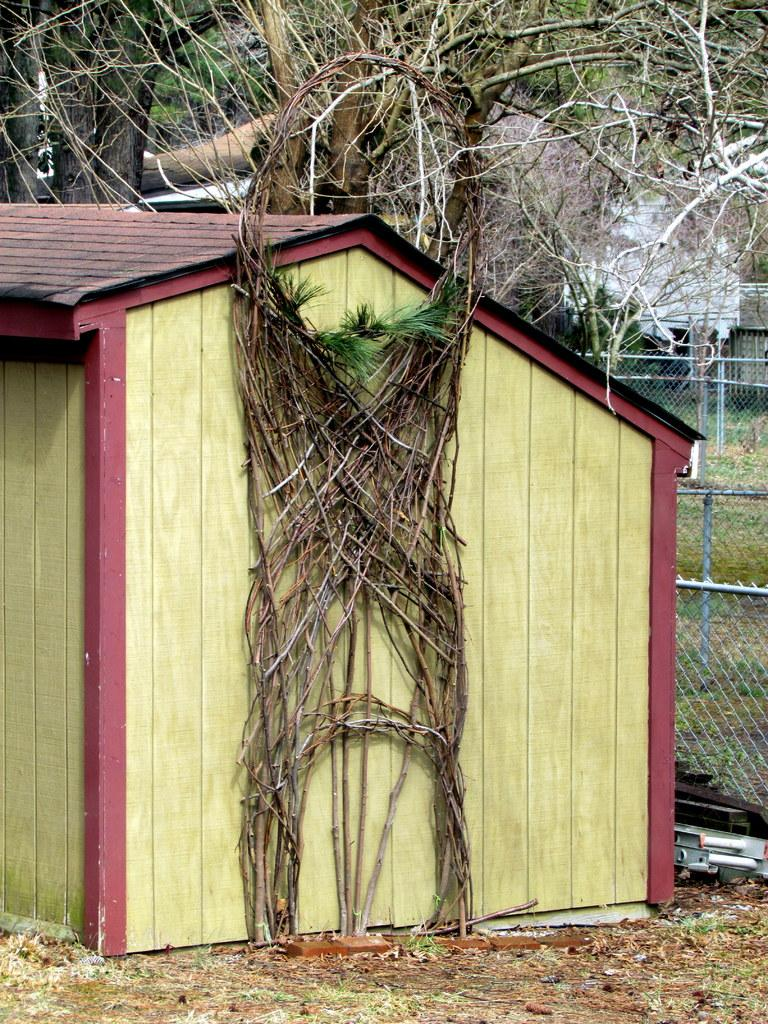What is the main structure in the center of the image? There is a shed in the center of the image. What can be seen in the background of the image? There are trees and a fence in the background of the image. What type of vegetation is visible at the bottom of the image? There is grass at the bottom of the image. How many spiders are crawling on the shed in the image? There are no spiders visible in the image; the focus is on the shed, trees, fence, and grass. 